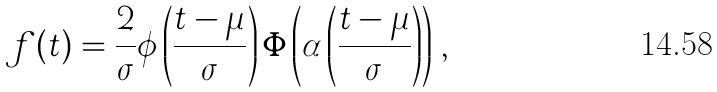<formula> <loc_0><loc_0><loc_500><loc_500>f ( t ) = \frac { 2 } { \sigma } \phi \left ( \frac { t - \mu } { \sigma } \right ) \Phi \left ( \alpha \left ( \frac { t - \mu } { \sigma } \right ) \right ) \, ,</formula> 